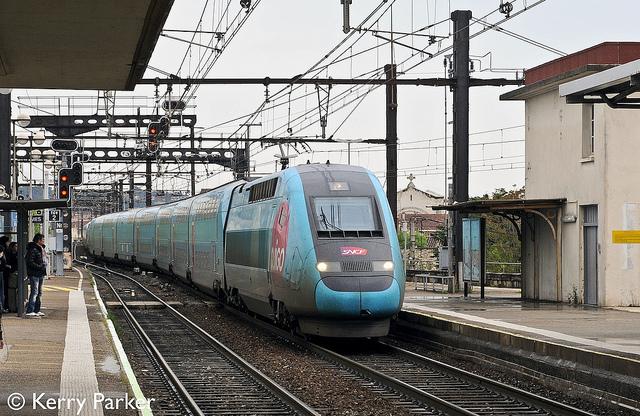Is this a big train station?
Answer briefly. No. Why are people waiting here?
Concise answer only. Train. What color is the train?
Quick response, please. Blue. 